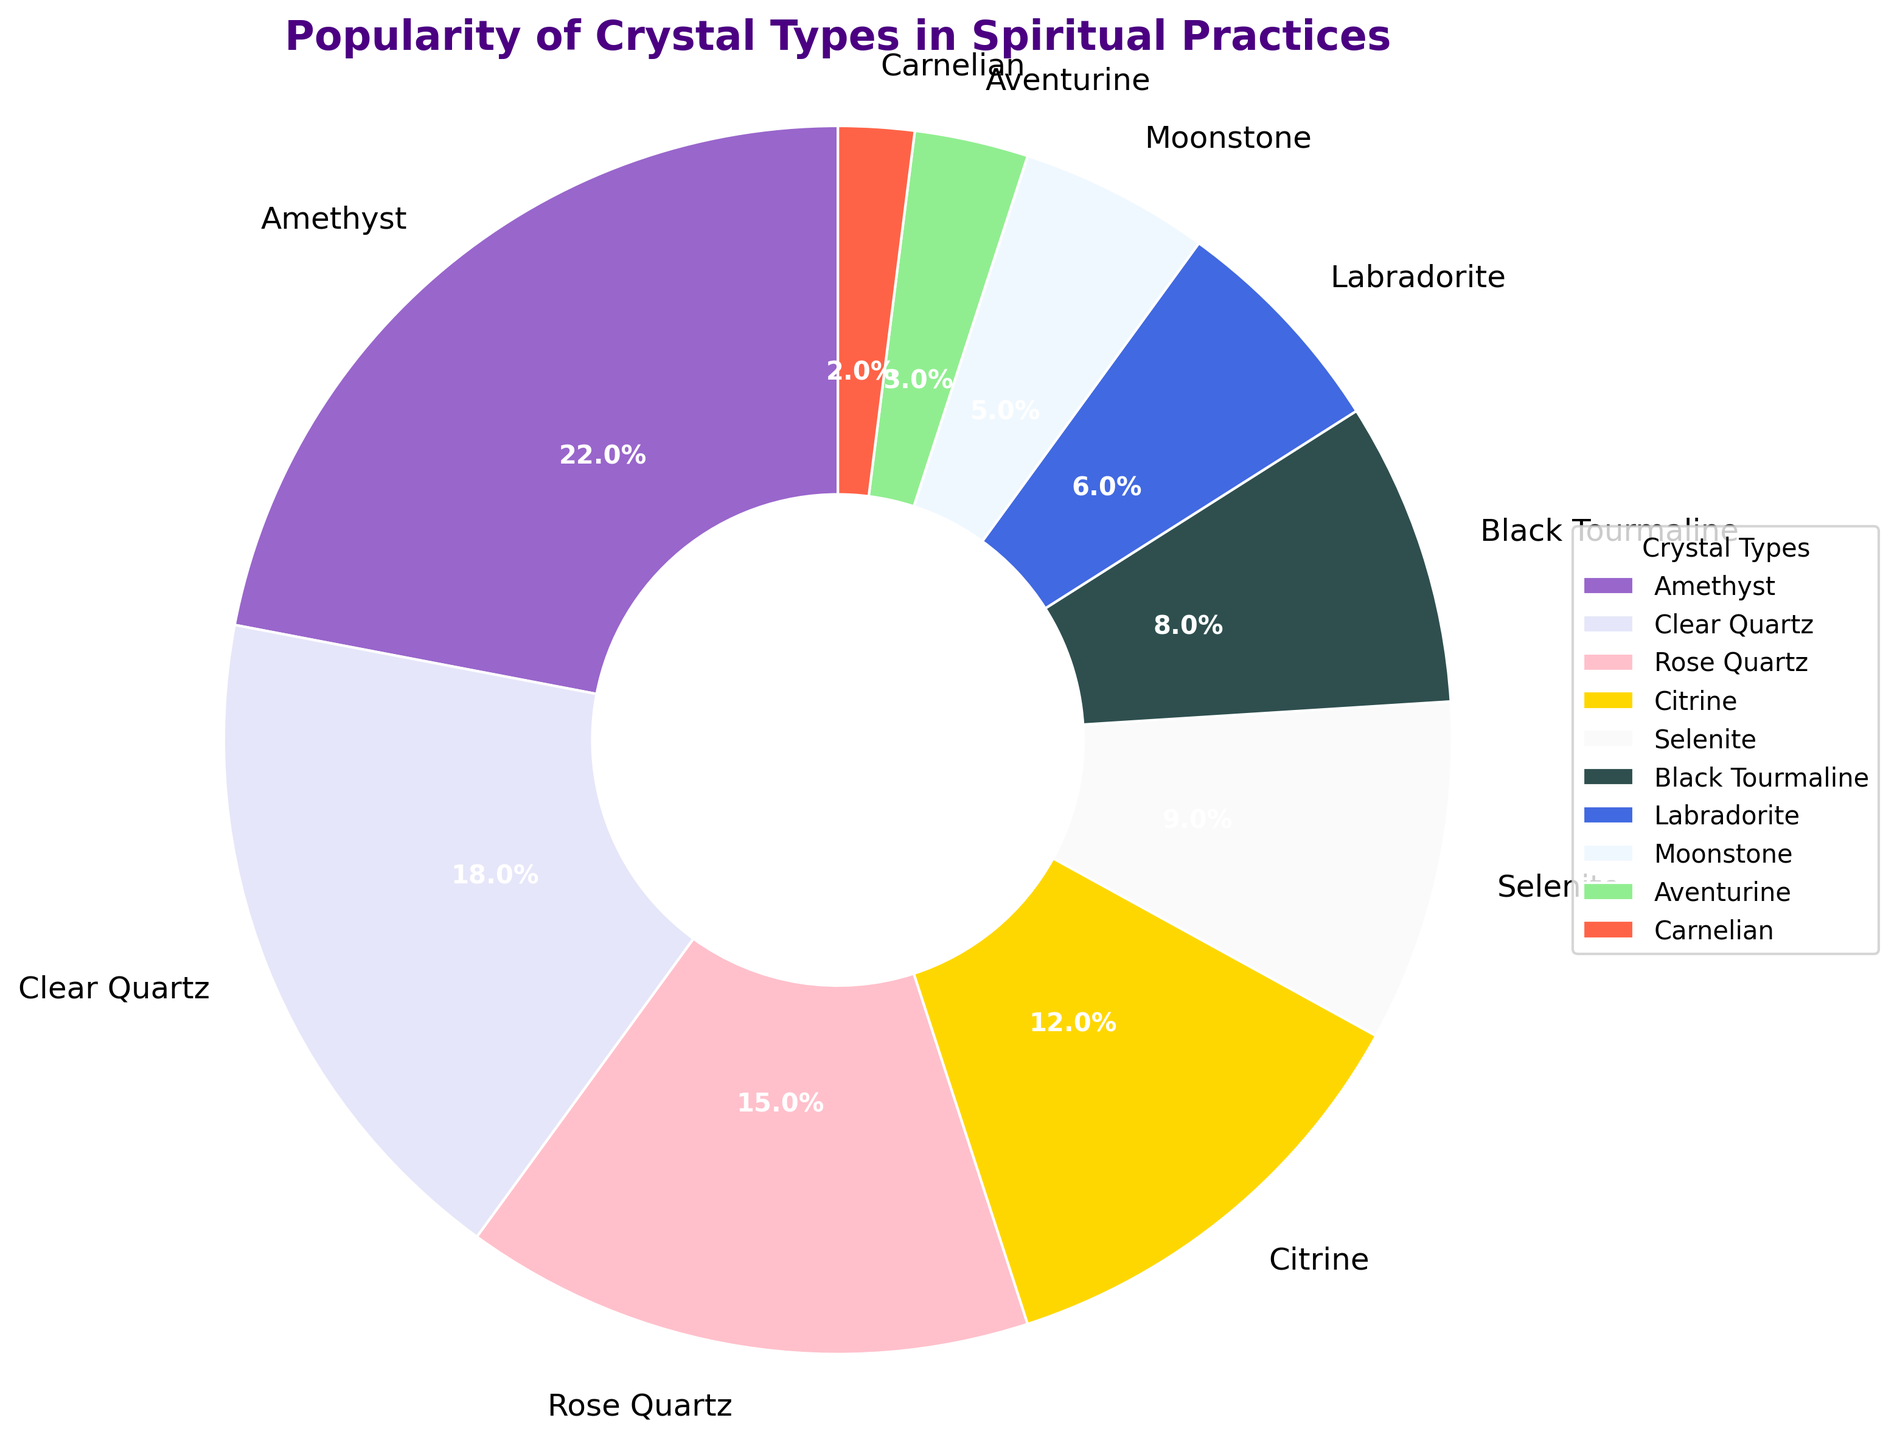what percentage of the pie chart is taken up by the top two most popular crystals, Amethyst and Clear Quartz? Add the percentages of Amethyst (22%) and Clear Quartz (18%) to find the total percentage for the top two crystals. 22% + 18% = 40%
Answer: 40% Which crystal is more popular, Rose Quartz or Citrine? Compare the percentages of Rose Quartz (15%) and Citrine (12%) and see which is greater. Rose Quartz has a higher percentage.
Answer: Rose Quartz How much more popular is Amethyst compared to Selenite? Subtract the percentage of Selenite (9%) from the percentage of Amethyst (22%) to find the difference. 22% - 9% = 13%
Answer: 13% What is the combined popularity percentage of Black Tourmaline and Labradorite? Add the percentages of Black Tourmaline (8%) and Labradorite (6%) to find the combined percentage. 8% + 6% = 14%
Answer: 14% If we merge the least popular crystals (Aventurine and Carnelian) together, what will their combined percentage be? Add the percentages of Aventurine (3%) and Carnelian (2%) to find the total percentage. 3% + 2% = 5%
Answer: 5% Which crystal has the smallest portion in the pie chart, and what is its percentage? Identify the crystal with the smallest percentage, which is Carnelian with 2%.
Answer: Carnelian, 2% How many crystals have a popularity percentage less than 10%? Count the crystals with percentages less than 10%, which are Selenite, Black Tourmaline, Labradorite, Moonstone, Aventurine, and Carnelian. There are six such crystals.
Answer: Six What's the average popularity percentage of Clear Quartz, Rose Quartz, and Citrine? Add the percentages of Clear Quartz (18%), Rose Quartz (15%), and Citrine (12%) and then divide by 3. (18 + 15 + 12) / 3 = 45 / 3 = 15%
Answer: 15% Which crystals collectively make up 50% of the chart? Add the percentages of the most popular crystals until reaching or exceeding 50%. Amethyst (22%) + Clear Quartz (18%) + Rose Quartz (15%) = 55%, so these three crystals collectively make up more than 50%.
Answer: Amethyst, Clear Quartz, Rose Quartz What color is the section representing Moonstone in the pie chart? Identify the color of the section labeled as Moonstone, which is a very light (almost white) color.
Answer: Light blue 